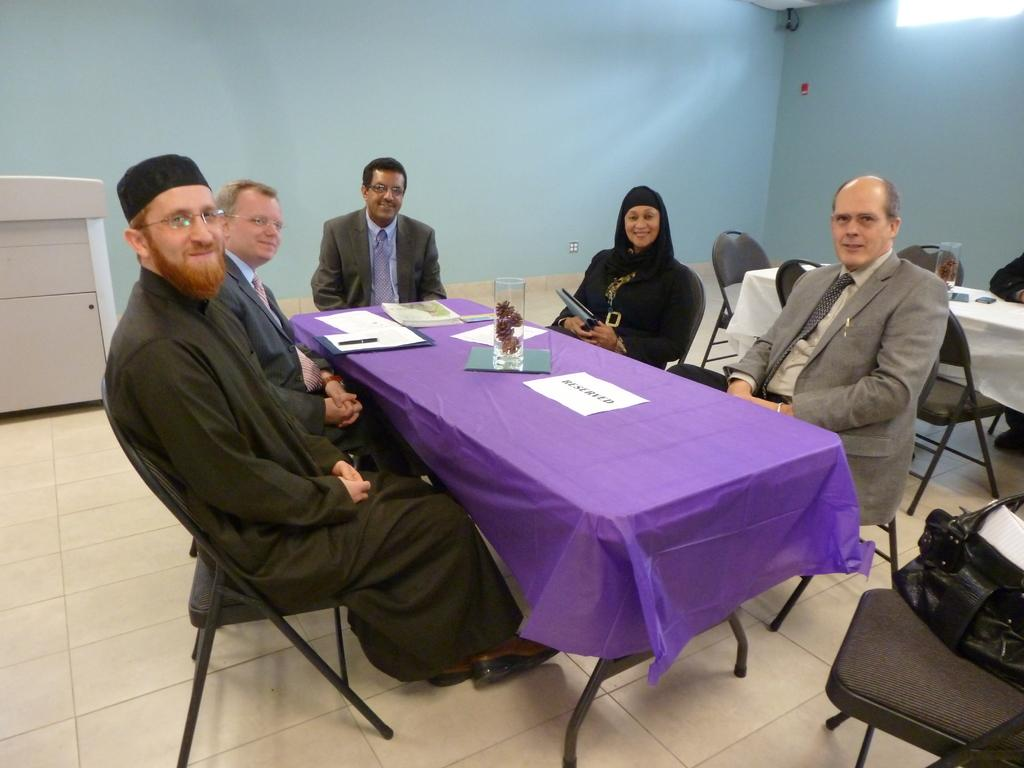What is the main subject of the image? The main subject of the image is a group of people. What are the people in the image doing? The people are sitting on chairs. Is there any furniture present in the image besides the chairs? Yes, there is a table in front of the group of people. What type of church can be seen in the background of the image? There is no church visible in the image; it only features a group of people sitting on chairs with a table in front of them. 